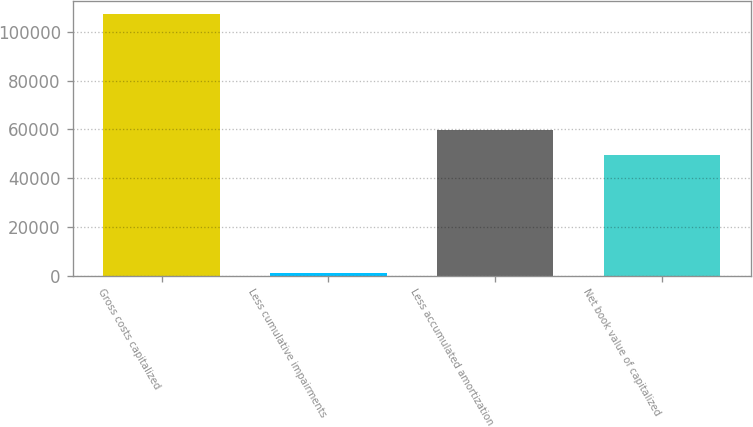<chart> <loc_0><loc_0><loc_500><loc_500><bar_chart><fcel>Gross costs capitalized<fcel>Less cumulative impairments<fcel>Less accumulated amortization<fcel>Net book value of capitalized<nl><fcel>107125<fcel>1050<fcel>59904.5<fcel>49297<nl></chart> 